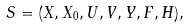<formula> <loc_0><loc_0><loc_500><loc_500>S = ( X , X _ { 0 } , U , V , Y , F , H ) ,</formula> 